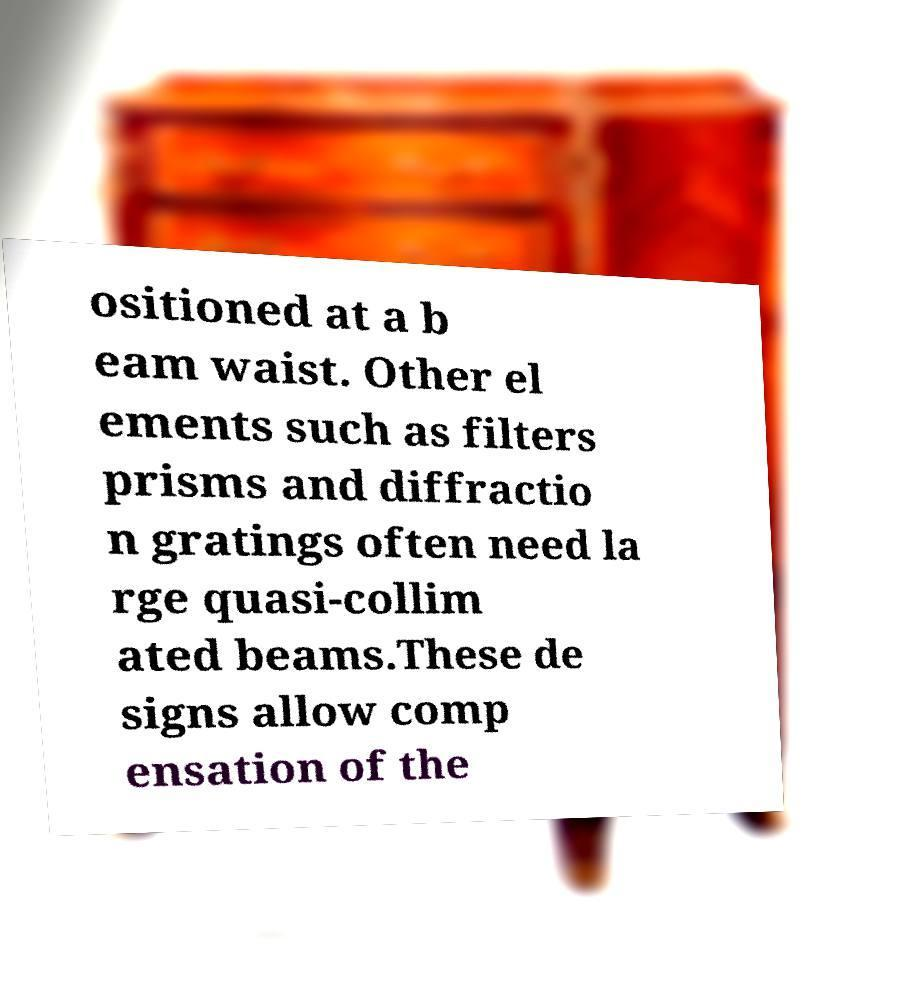Can you read and provide the text displayed in the image?This photo seems to have some interesting text. Can you extract and type it out for me? ositioned at a b eam waist. Other el ements such as filters prisms and diffractio n gratings often need la rge quasi-collim ated beams.These de signs allow comp ensation of the 